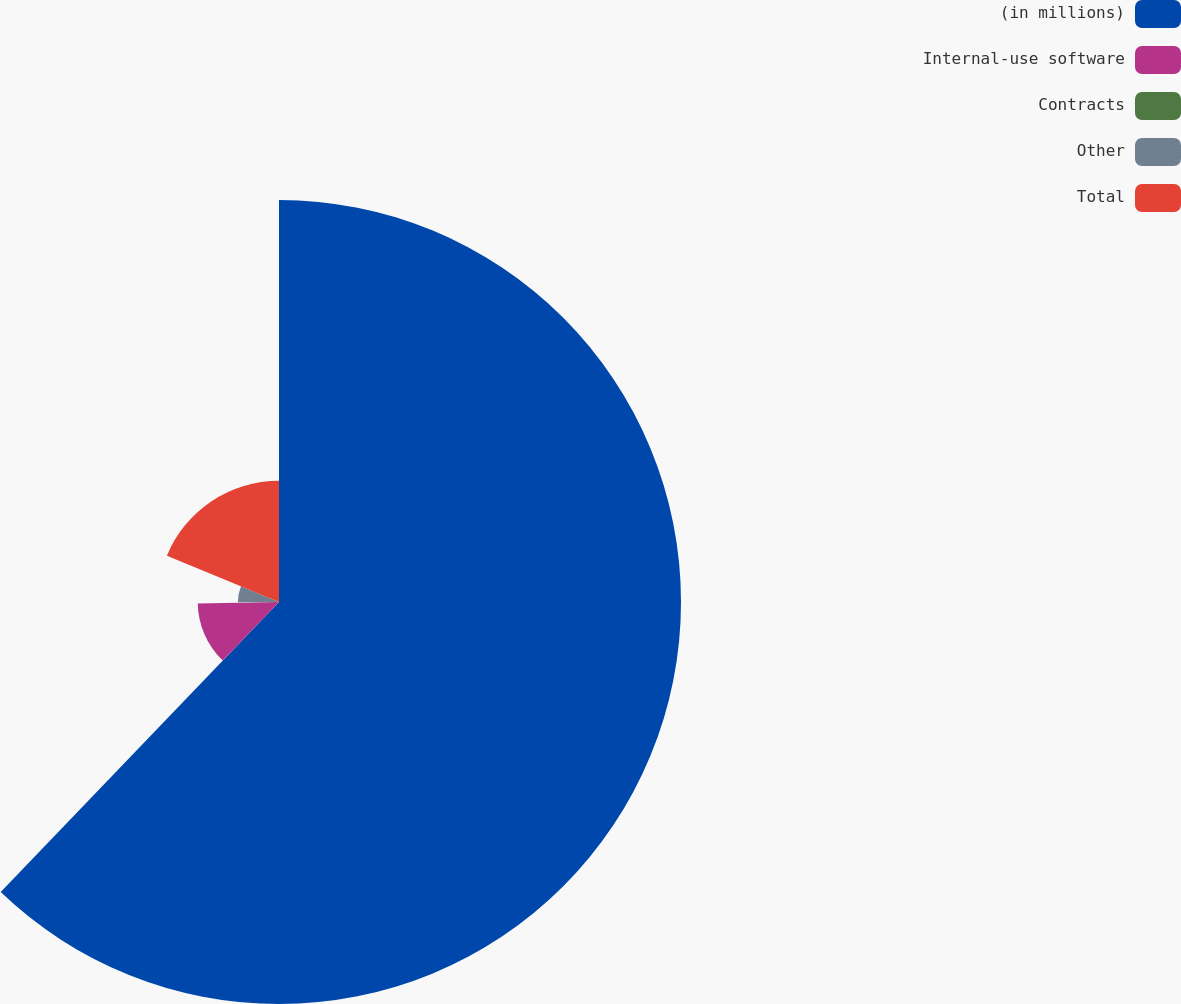Convert chart to OTSL. <chart><loc_0><loc_0><loc_500><loc_500><pie_chart><fcel>(in millions)<fcel>Internal-use software<fcel>Contracts<fcel>Other<fcel>Total<nl><fcel>62.17%<fcel>12.56%<fcel>0.15%<fcel>6.36%<fcel>18.76%<nl></chart> 